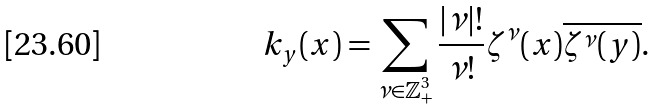Convert formula to latex. <formula><loc_0><loc_0><loc_500><loc_500>k _ { y } ( x ) = \sum _ { \nu \in { \mathbb { Z } } ^ { 3 } _ { + } } \frac { | \nu | ! } { \nu ! } \zeta ^ { \nu } ( x ) \overline { \zeta ^ { \nu } ( y ) } .</formula> 